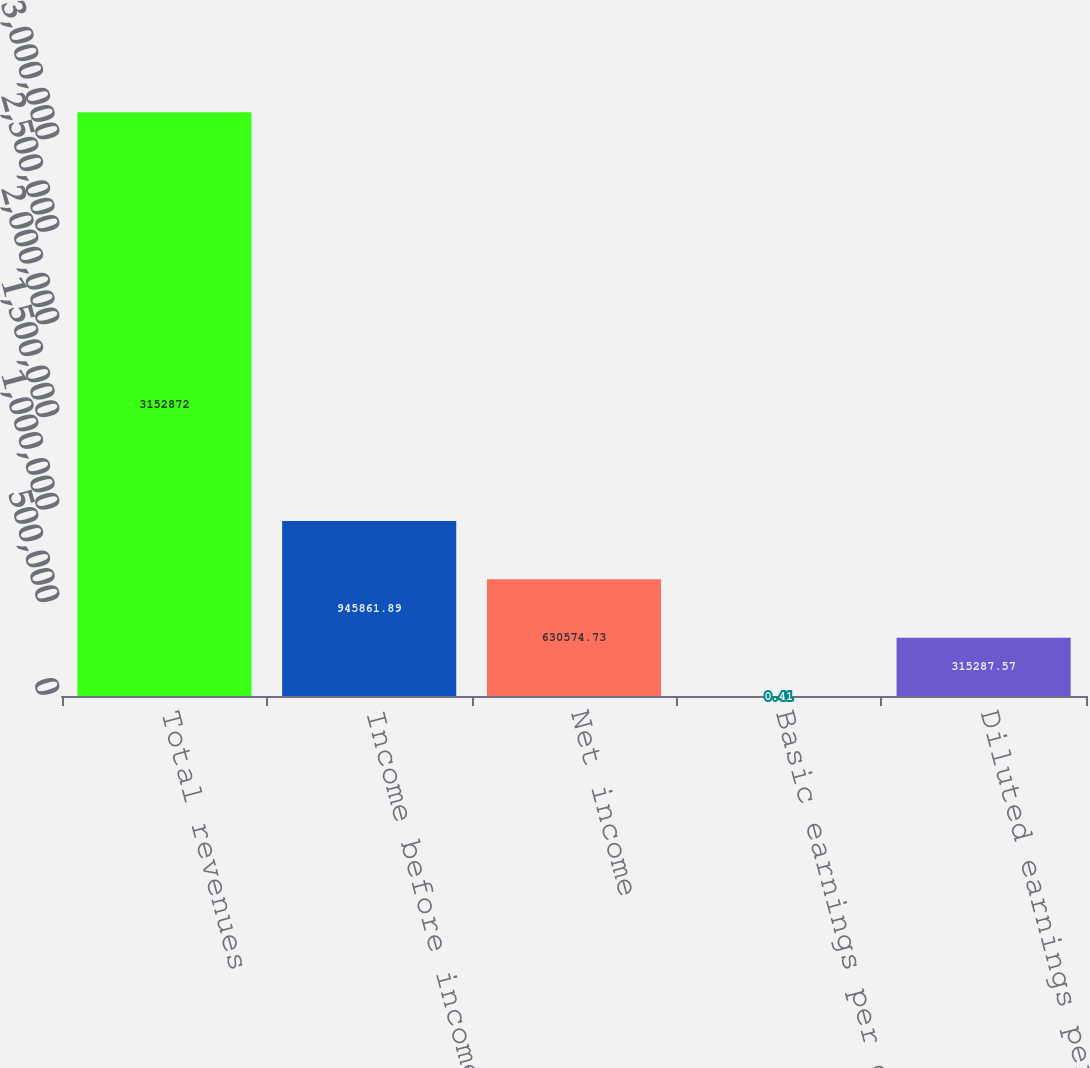<chart> <loc_0><loc_0><loc_500><loc_500><bar_chart><fcel>Total revenues<fcel>Income before income taxes<fcel>Net income<fcel>Basic earnings per common<fcel>Diluted earnings per common<nl><fcel>3.15287e+06<fcel>945862<fcel>630575<fcel>0.41<fcel>315288<nl></chart> 